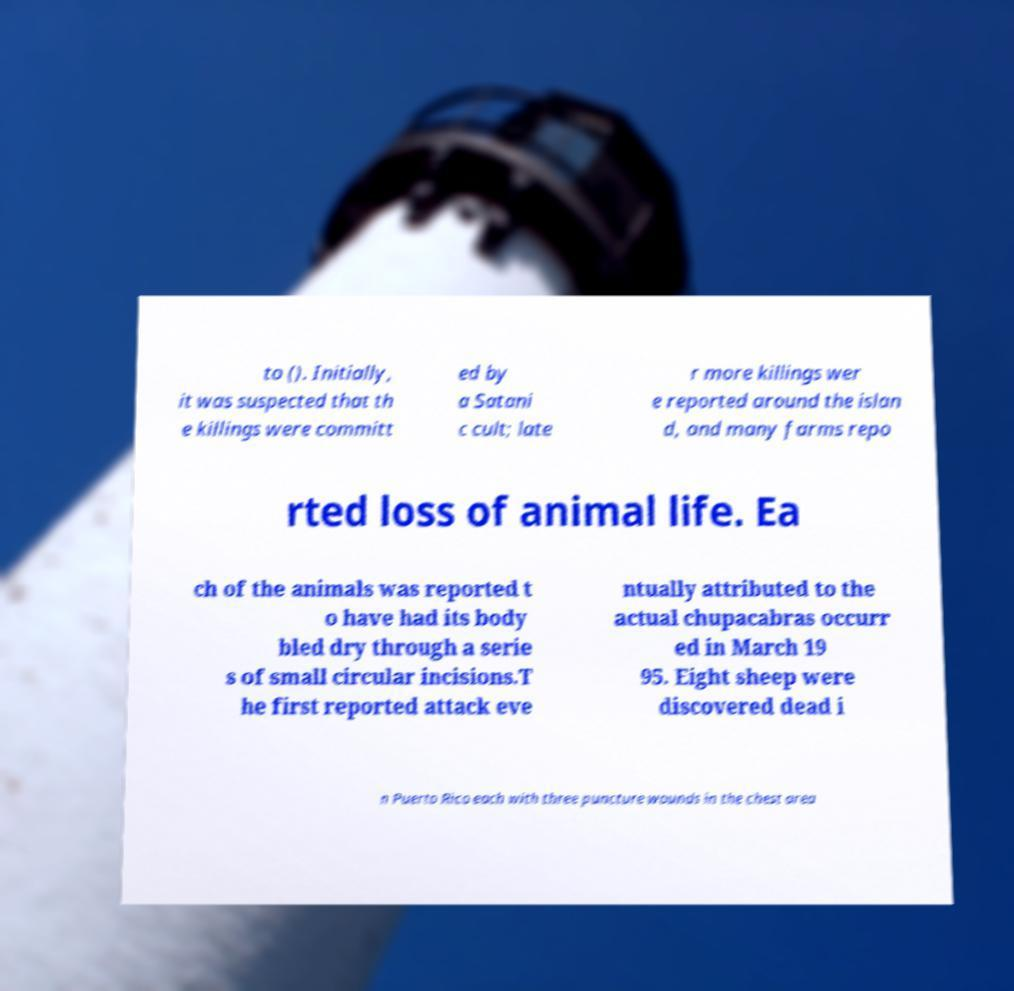Could you extract and type out the text from this image? to (). Initially, it was suspected that th e killings were committ ed by a Satani c cult; late r more killings wer e reported around the islan d, and many farms repo rted loss of animal life. Ea ch of the animals was reported t o have had its body bled dry through a serie s of small circular incisions.T he first reported attack eve ntually attributed to the actual chupacabras occurr ed in March 19 95. Eight sheep were discovered dead i n Puerto Rico each with three puncture wounds in the chest area 